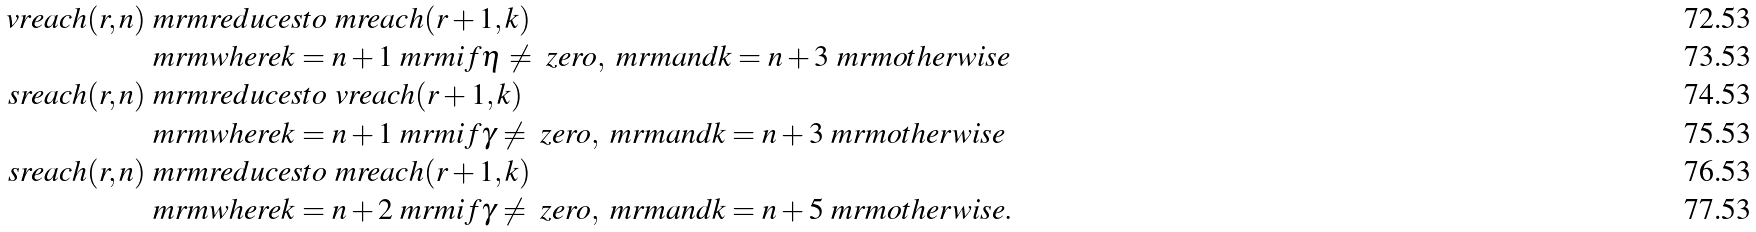<formula> <loc_0><loc_0><loc_500><loc_500>\ v r e a c h ( r , n ) & \ m r m { r e d u c e s t o } \ m r e a c h ( r + 1 , k ) \\ & \ m r m { w h e r e } k = n + 1 \ m r m { i f } \eta \neq \ z e r o , \ m r m { a n d } k = n + 3 \ m r m { o t h e r w i s e } \\ \ s r e a c h ( r , n ) & \ m r m { r e d u c e s t o } \ v r e a c h ( r + 1 , k ) \\ & \ m r m { w h e r e } k = n + 1 \ m r m { i f } \gamma \neq \ z e r o , \ m r m { a n d } k = n + 3 \ m r m { o t h e r w i s e } \\ \ s r e a c h ( r , n ) & \ m r m { r e d u c e s t o } \ m r e a c h ( r + 1 , k ) \\ & \ m r m { w h e r e } k = n + 2 \ m r m { i f } \gamma \neq \ z e r o , \ m r m { a n d } k = n + 5 \ m r m { o t h e r w i s e . }</formula> 